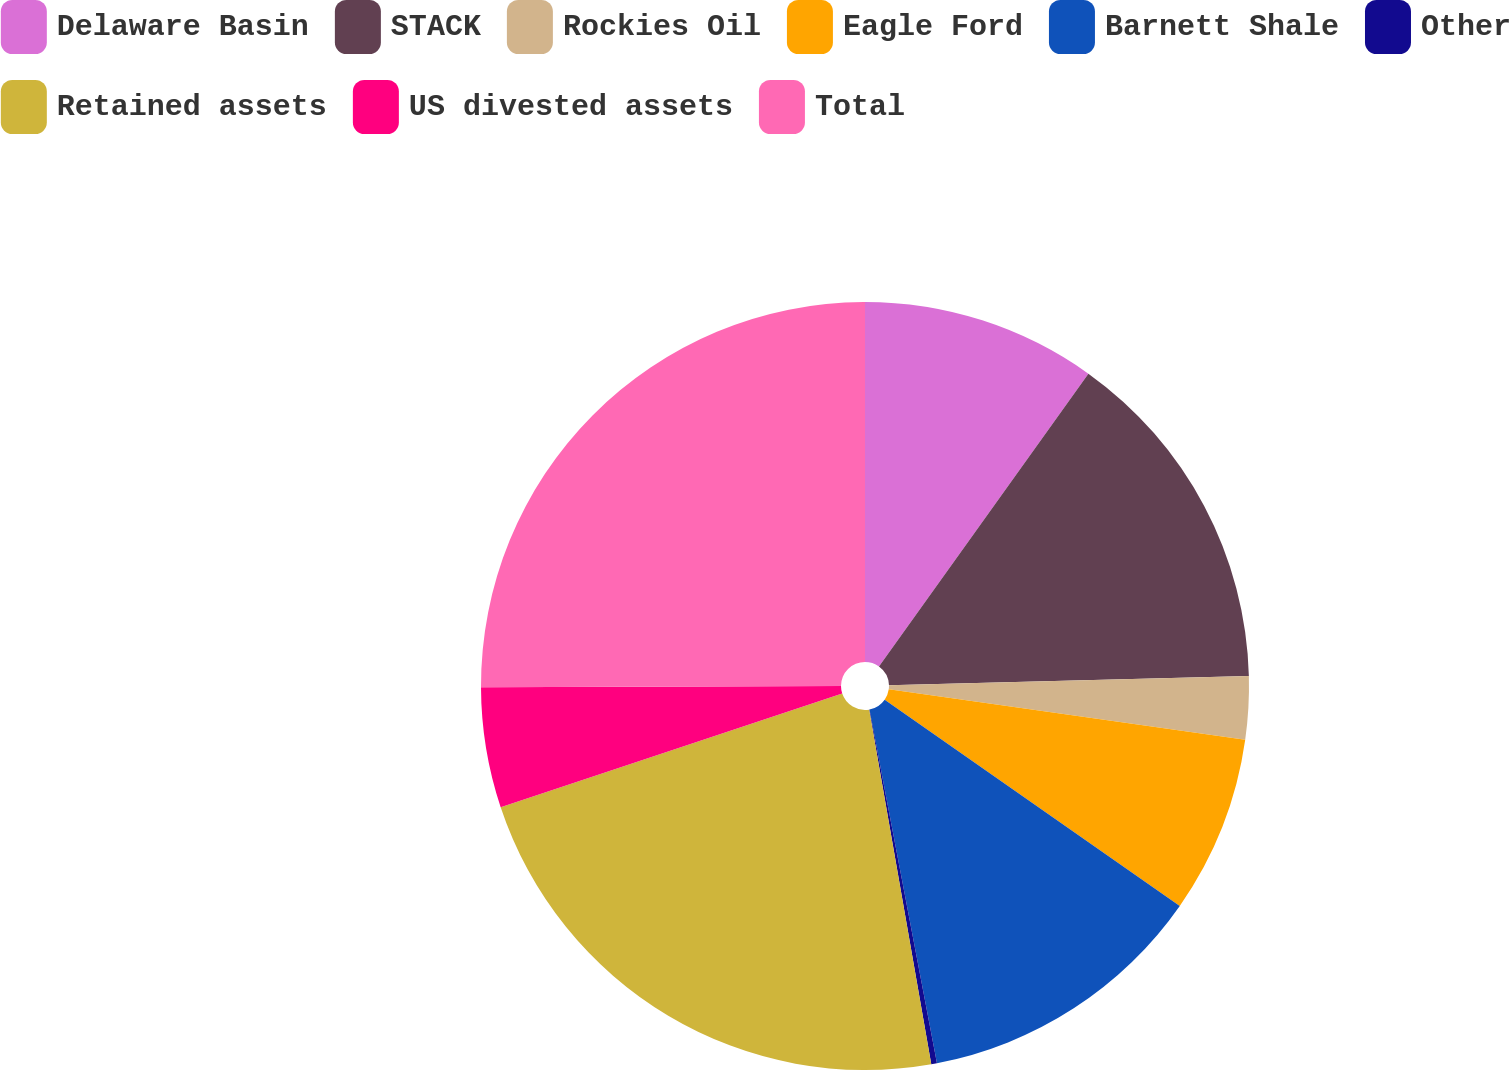Convert chart. <chart><loc_0><loc_0><loc_500><loc_500><pie_chart><fcel>Delaware Basin<fcel>STACK<fcel>Rockies Oil<fcel>Eagle Ford<fcel>Barnett Shale<fcel>Other<fcel>Retained assets<fcel>US divested assets<fcel>Total<nl><fcel>9.88%<fcel>14.7%<fcel>2.65%<fcel>7.47%<fcel>12.29%<fcel>0.24%<fcel>22.64%<fcel>5.06%<fcel>25.05%<nl></chart> 